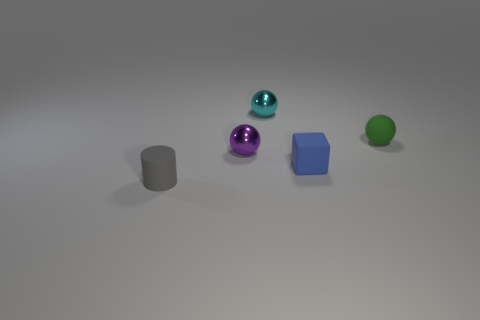Subtract all metallic balls. How many balls are left? 1 Add 1 blue matte cubes. How many objects exist? 6 Subtract all purple balls. How many balls are left? 2 Subtract 1 cylinders. How many cylinders are left? 0 Subtract all balls. How many objects are left? 2 Subtract all red cubes. Subtract all green balls. How many cubes are left? 1 Subtract all gray matte cylinders. Subtract all large gray metal cylinders. How many objects are left? 4 Add 3 small gray objects. How many small gray objects are left? 4 Add 3 small cylinders. How many small cylinders exist? 4 Subtract 0 blue balls. How many objects are left? 5 